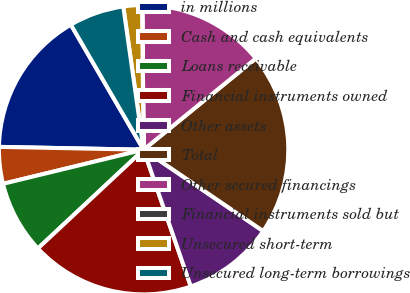Convert chart to OTSL. <chart><loc_0><loc_0><loc_500><loc_500><pie_chart><fcel>in millions<fcel>Cash and cash equivalents<fcel>Loans receivable<fcel>Financial instruments owned<fcel>Other assets<fcel>Total<fcel>Other secured financings<fcel>Financial instruments sold but<fcel>Unsecured short-term<fcel>Unsecured long-term borrowings<nl><fcel>16.3%<fcel>4.1%<fcel>8.17%<fcel>18.33%<fcel>10.2%<fcel>20.37%<fcel>14.27%<fcel>0.04%<fcel>2.07%<fcel>6.14%<nl></chart> 